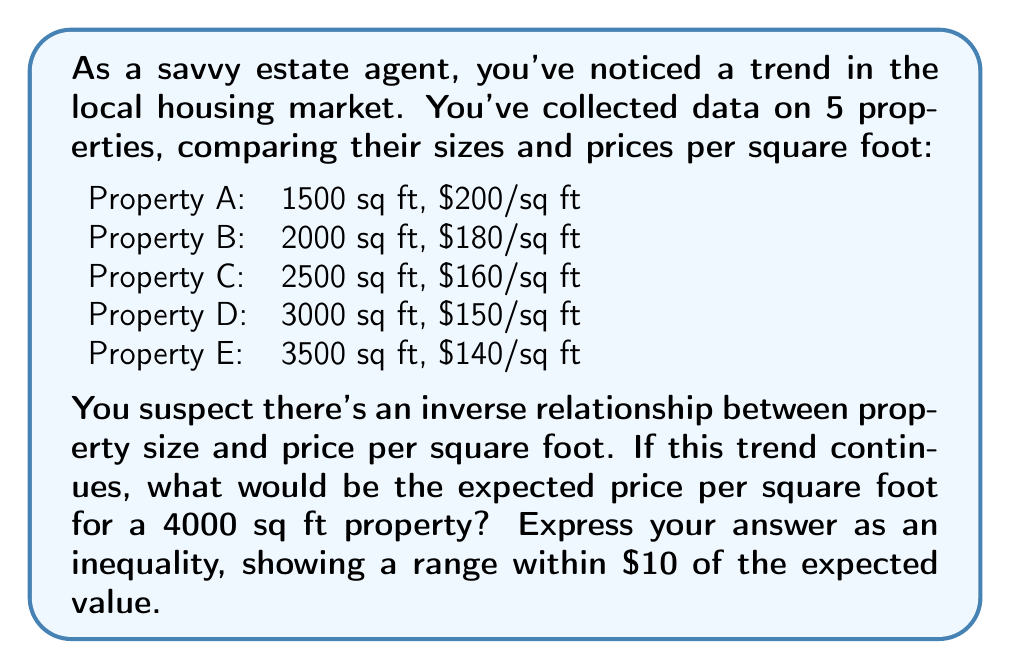Show me your answer to this math problem. To solve this problem, we need to:

1. Analyze the relationship between property size and price per square foot.
2. Find a mathematical model for this relationship.
3. Use the model to predict the price per square foot for a 4000 sq ft property.
4. Express the result as an inequality.

Step 1: Analyzing the relationship

Let's plot the data points:

[asy]
size(300,200);
real[] x = {1500,2000,2500,3000,3500};
real[] y = {200,180,160,150,140};
for(int i=0; i<5; ++i) {
  dot((x[i]/100,y[i]));
}
draw((0,220)--(40,120));
xaxis("Property Size (100 sq ft)",0,40,Arrow);
yaxis("Price per sq ft ($)",120,220,Arrow);
label("A",(15,200),NE);
label("B",(20,180),NE);
label("C",(25,160),NE);
label("D",(30,150),NE);
label("E",(35,140),NE);
[/asy]

We can see that there's indeed an inverse relationship between property size and price per square foot.

Step 2: Finding a mathematical model

The relationship appears to be roughly linear. We can use the line of best fit, but for simplicity, let's use the line connecting the first and last data points:

$$ y = mx + b $$

Where $y$ is the price per square foot, and $x$ is the property size in hundreds of square feet.

Using points A (15, 200) and E (35, 140):

$$ m = \frac{140 - 200}{35 - 15} = -3 $$

$$ 200 = -3(15) + b $$
$$ b = 245 $$

So our model is:

$$ y = -3x + 245 $$

Step 3: Predicting the price for a 4000 sq ft property

For a 4000 sq ft property, $x = 40$:

$$ y = -3(40) + 245 = 125 $$

Step 4: Expressing as an inequality

We want to show a range within $10 of the expected value:

$$ 115 < y \leq 135 $$
Answer: $115 < y \leq 135$, where $y$ is the expected price per square foot for a 4000 sq ft property. 